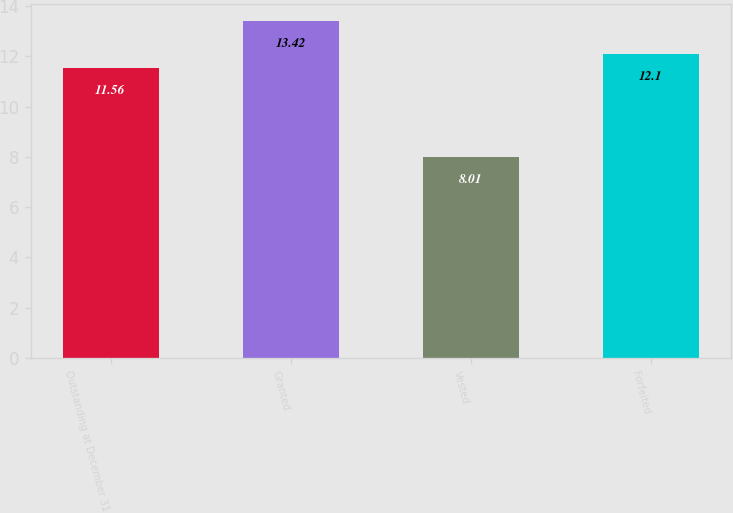<chart> <loc_0><loc_0><loc_500><loc_500><bar_chart><fcel>Outstanding at December 31<fcel>Granted<fcel>Vested<fcel>Forfeited<nl><fcel>11.56<fcel>13.42<fcel>8.01<fcel>12.1<nl></chart> 